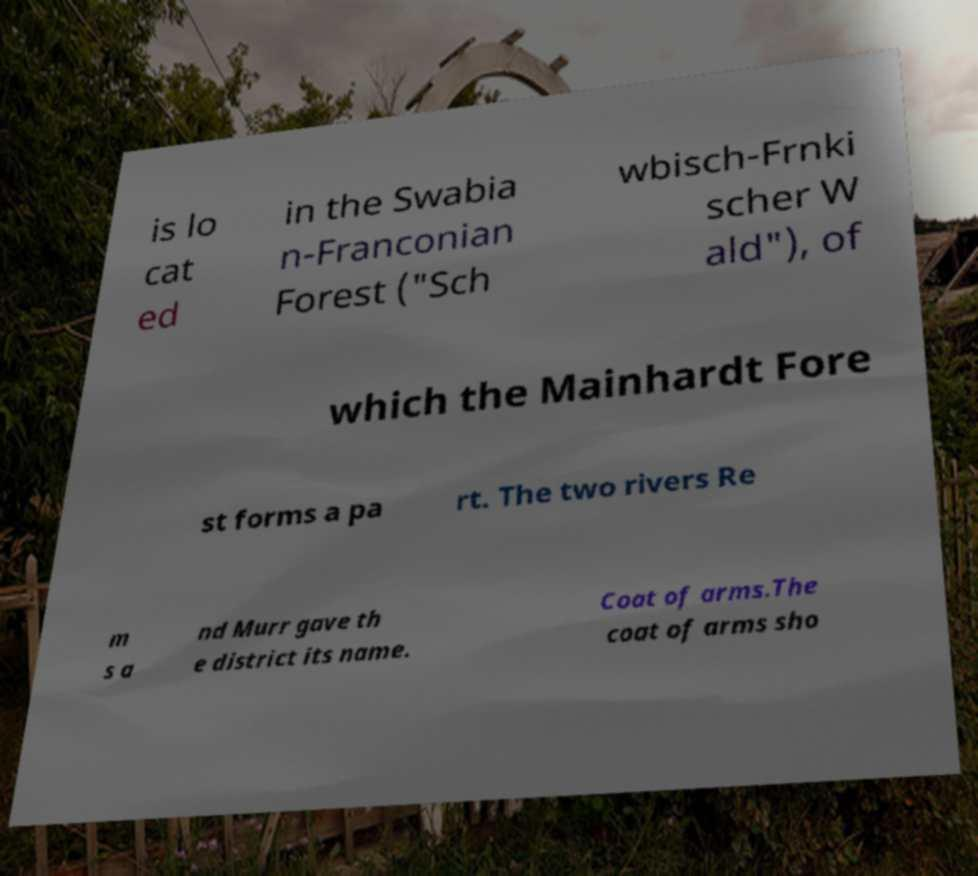Can you accurately transcribe the text from the provided image for me? is lo cat ed in the Swabia n-Franconian Forest ("Sch wbisch-Frnki scher W ald"), of which the Mainhardt Fore st forms a pa rt. The two rivers Re m s a nd Murr gave th e district its name. Coat of arms.The coat of arms sho 